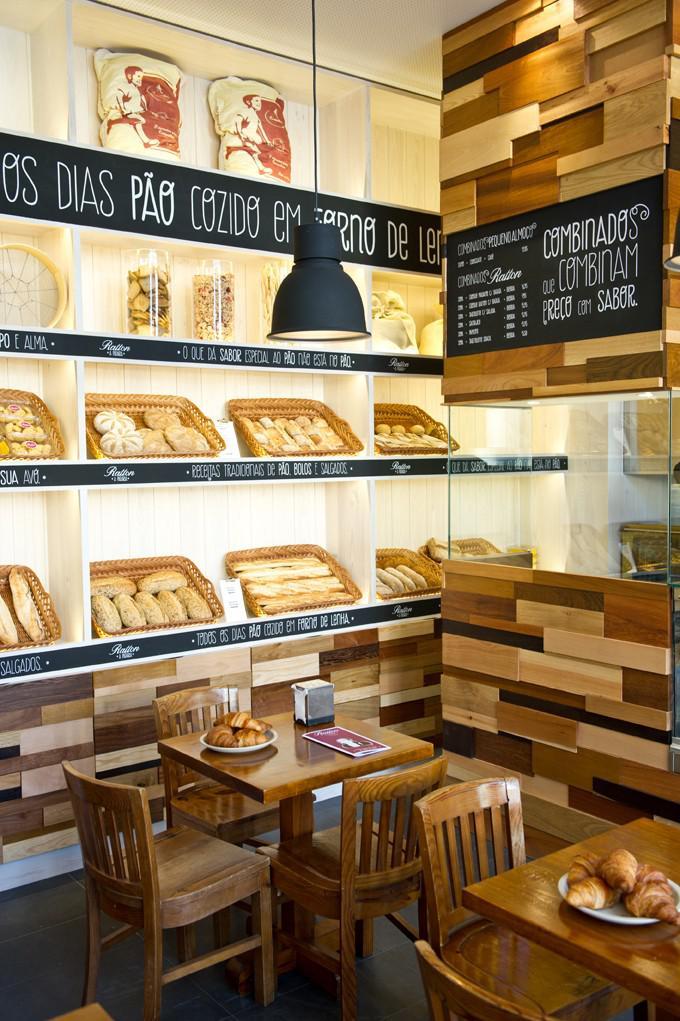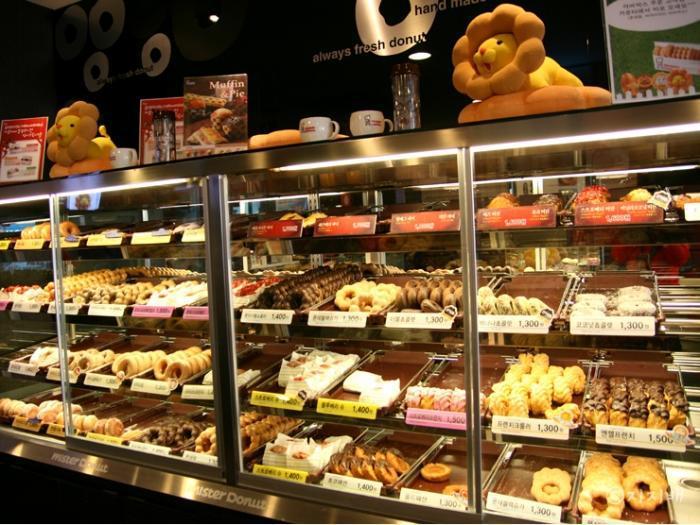The first image is the image on the left, the second image is the image on the right. Given the left and right images, does the statement "The left image features at least one pendant light in the bakery." hold true? Answer yes or no. Yes. The first image is the image on the left, the second image is the image on the right. Analyze the images presented: Is the assertion "There are baked goods in baskets in one of the images." valid? Answer yes or no. Yes. 